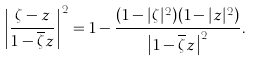Convert formula to latex. <formula><loc_0><loc_0><loc_500><loc_500>\left | \frac { \zeta - z } { 1 - \overline { \zeta } z } \right | ^ { 2 } = 1 - \frac { ( 1 - | \zeta | ^ { 2 } ) ( 1 - | z | ^ { 2 } ) } { \left | 1 - \overline { \zeta } z \right | ^ { 2 } } .</formula> 